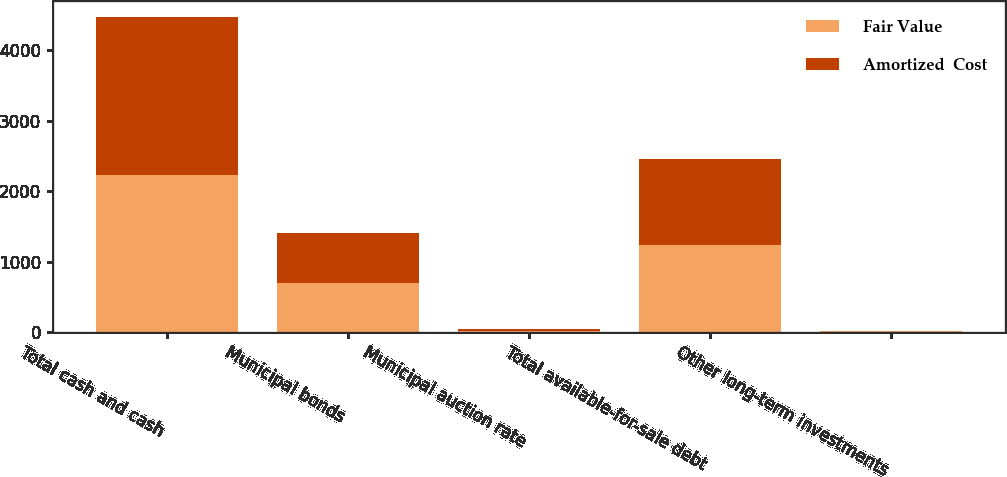Convert chart. <chart><loc_0><loc_0><loc_500><loc_500><stacked_bar_chart><ecel><fcel>Total cash and cash<fcel>Municipal bonds<fcel>Municipal auction rate<fcel>Total available-for-sale debt<fcel>Other long-term investments<nl><fcel>Fair Value<fcel>2233<fcel>700<fcel>21<fcel>1229<fcel>10<nl><fcel>Amortized  Cost<fcel>2234<fcel>701<fcel>21<fcel>1230<fcel>10<nl></chart> 